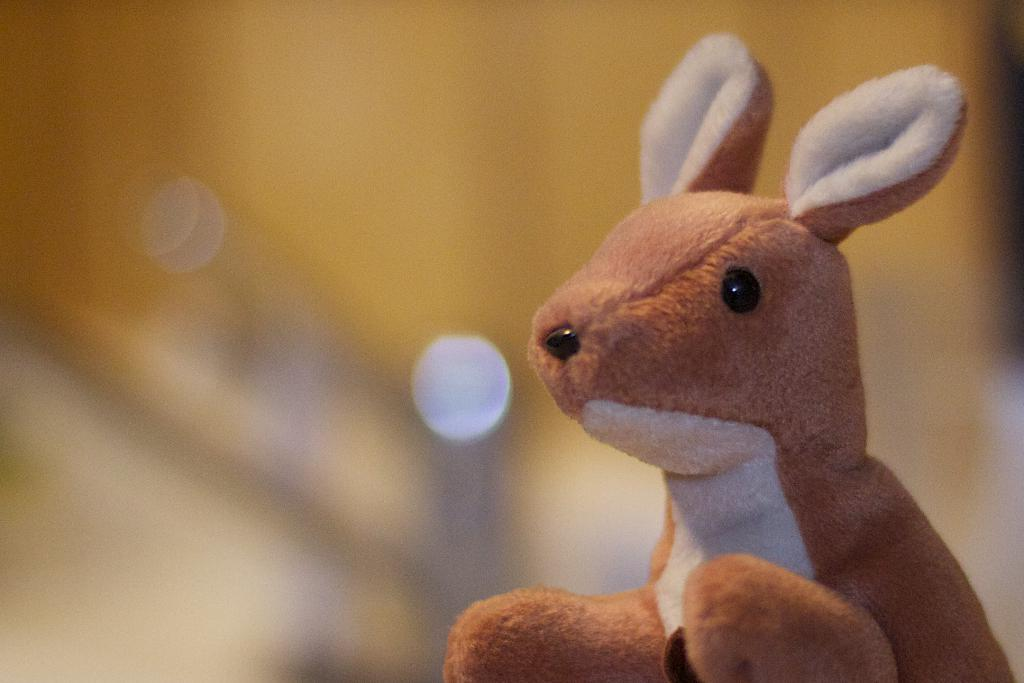What type of object can be seen in the image? There is a soft toy in the image. What type of soup is being served in the image? There is no soup present in the image; it features a soft toy. What is the answer to the question about the sweater in the image? There is no sweater present in the image, so there is no answer to that question. 